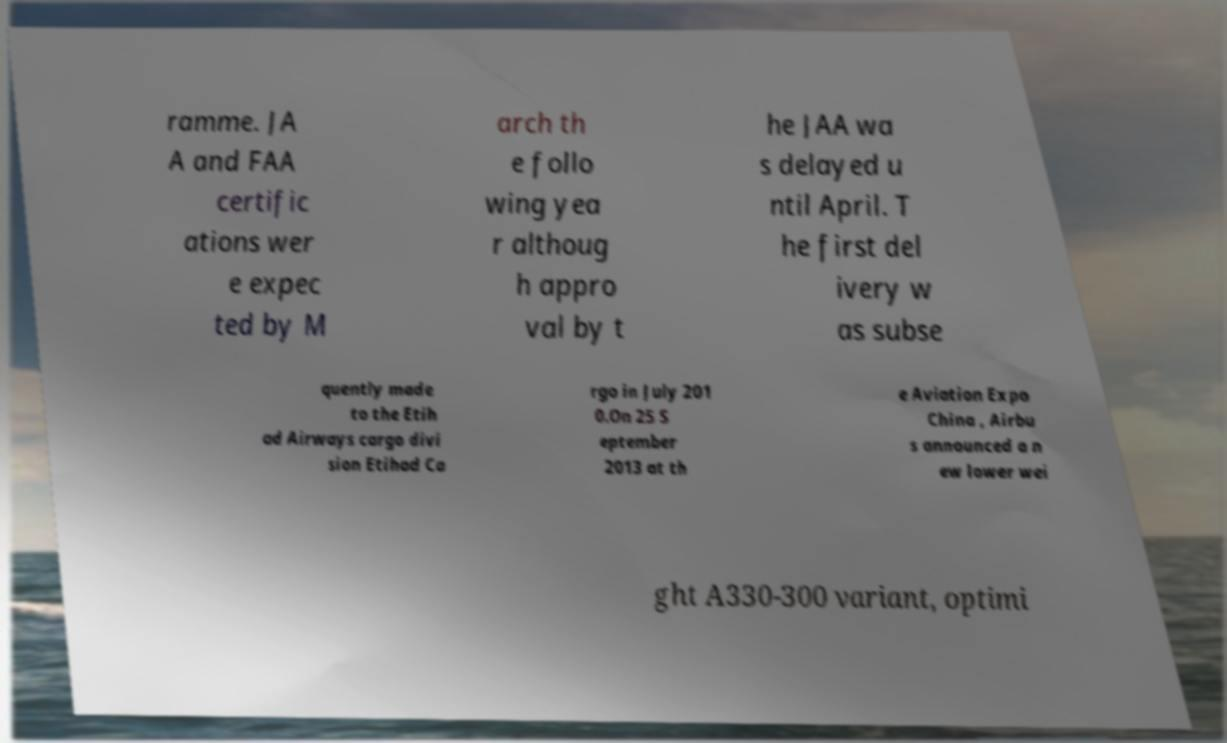There's text embedded in this image that I need extracted. Can you transcribe it verbatim? ramme. JA A and FAA certific ations wer e expec ted by M arch th e follo wing yea r althoug h appro val by t he JAA wa s delayed u ntil April. T he first del ivery w as subse quently made to the Etih ad Airways cargo divi sion Etihad Ca rgo in July 201 0.On 25 S eptember 2013 at th e Aviation Expo China , Airbu s announced a n ew lower wei ght A330-300 variant, optimi 